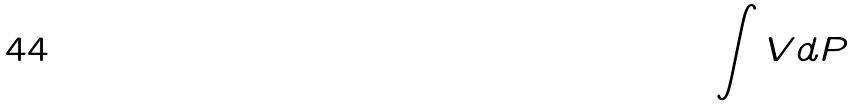<formula> <loc_0><loc_0><loc_500><loc_500>\int V d P</formula> 